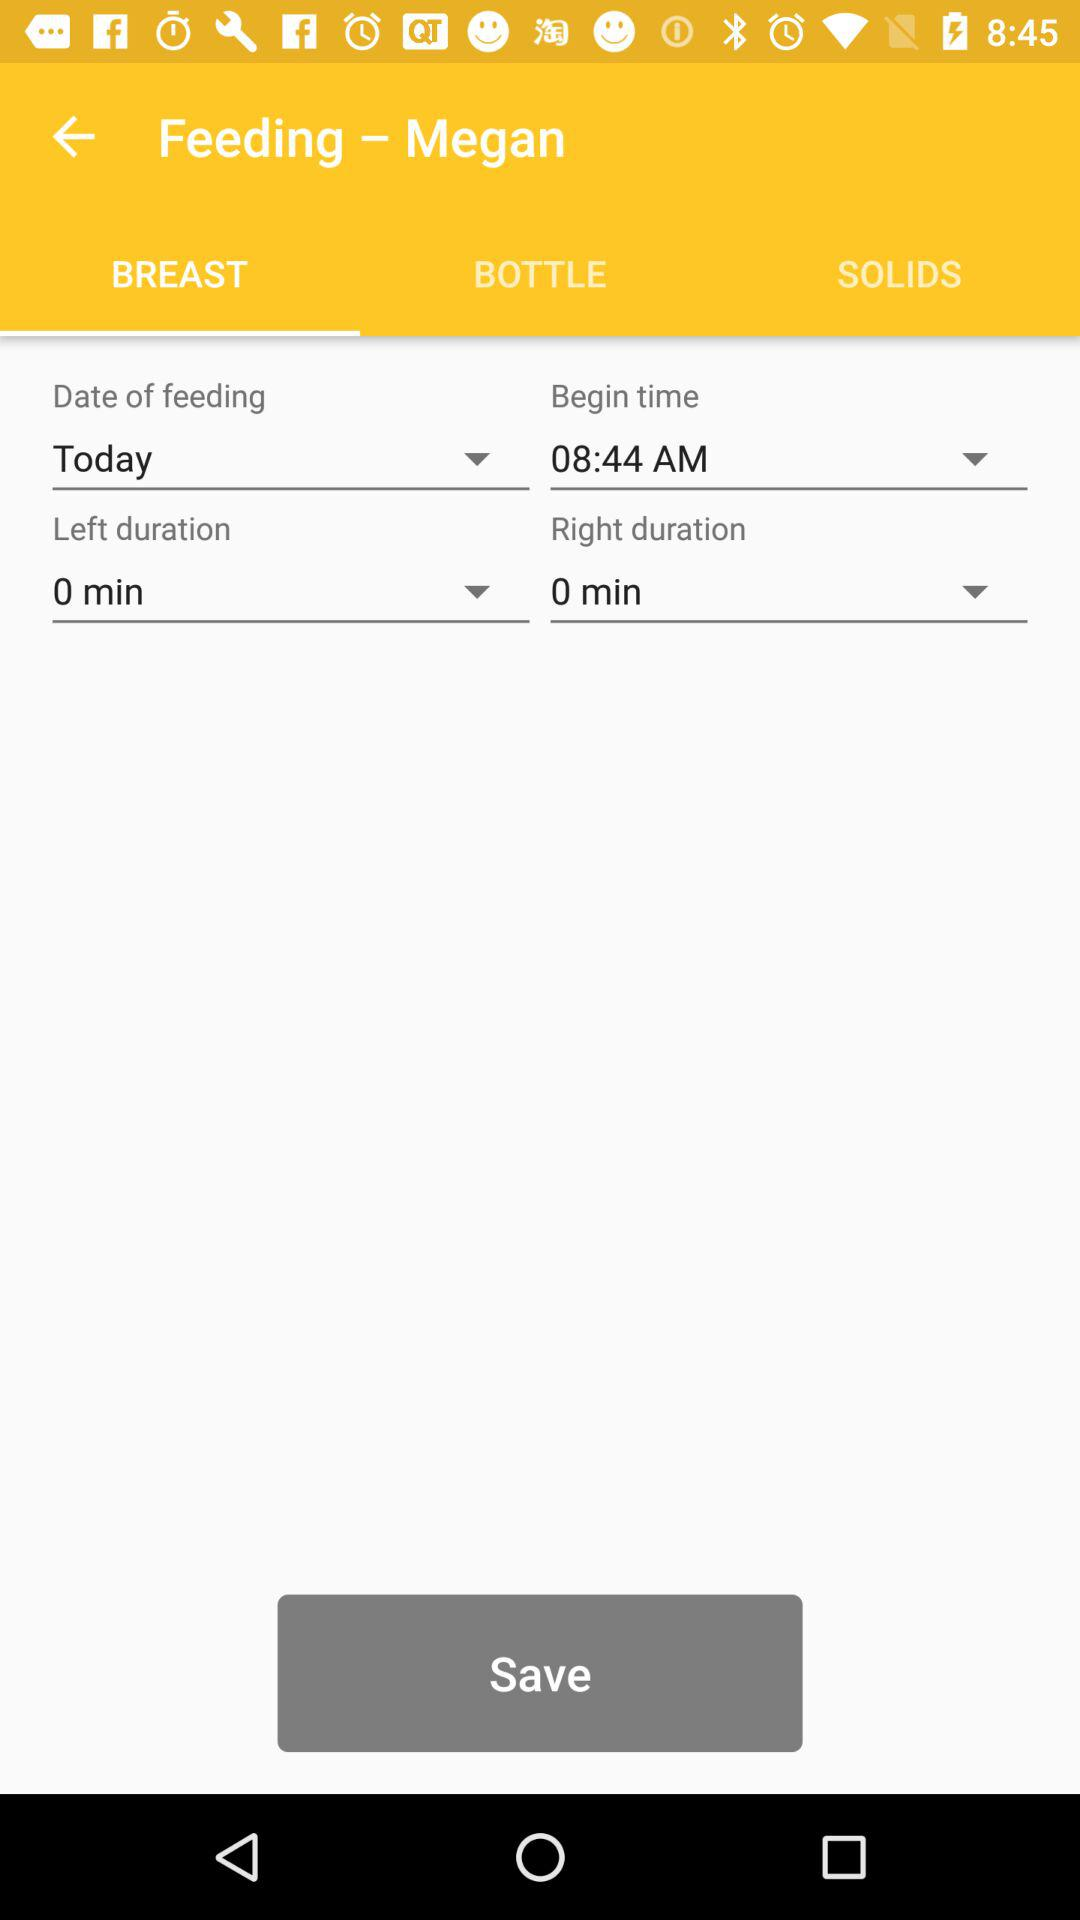What is the begin time? The begin time is 08:44 AM. 